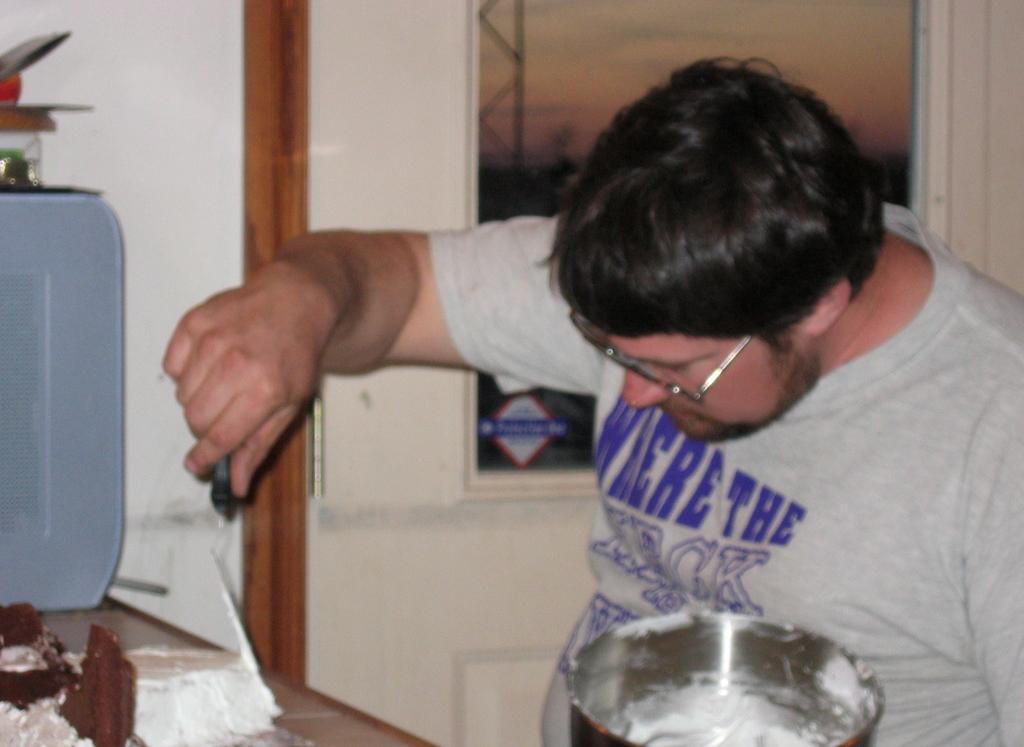What's the second word on his shirt?
Make the answer very short. The. What is the first word on his shirt?
Provide a short and direct response. Where. 